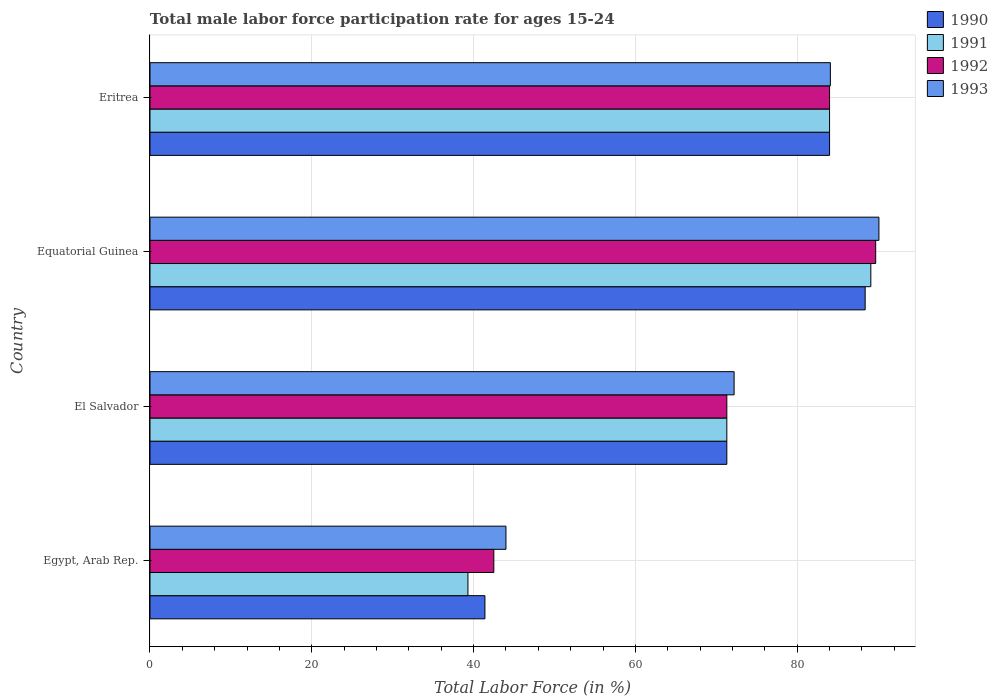How many different coloured bars are there?
Your response must be concise. 4. How many groups of bars are there?
Ensure brevity in your answer.  4. How many bars are there on the 2nd tick from the bottom?
Offer a very short reply. 4. What is the label of the 4th group of bars from the top?
Keep it short and to the point. Egypt, Arab Rep. What is the male labor force participation rate in 1990 in El Salvador?
Your response must be concise. 71.3. Across all countries, what is the maximum male labor force participation rate in 1990?
Your answer should be very brief. 88.4. In which country was the male labor force participation rate in 1991 maximum?
Offer a terse response. Equatorial Guinea. In which country was the male labor force participation rate in 1993 minimum?
Your answer should be compact. Egypt, Arab Rep. What is the total male labor force participation rate in 1991 in the graph?
Keep it short and to the point. 283.7. What is the difference between the male labor force participation rate in 1992 in Egypt, Arab Rep. and that in Equatorial Guinea?
Provide a succinct answer. -47.2. What is the difference between the male labor force participation rate in 1992 in Eritrea and the male labor force participation rate in 1990 in Equatorial Guinea?
Your response must be concise. -4.4. What is the average male labor force participation rate in 1993 per country?
Make the answer very short. 72.6. What is the difference between the male labor force participation rate in 1991 and male labor force participation rate in 1992 in Egypt, Arab Rep.?
Offer a terse response. -3.2. What is the ratio of the male labor force participation rate in 1993 in Egypt, Arab Rep. to that in Equatorial Guinea?
Your answer should be compact. 0.49. Is the male labor force participation rate in 1990 in Egypt, Arab Rep. less than that in Equatorial Guinea?
Offer a terse response. Yes. What is the difference between the highest and the second highest male labor force participation rate in 1992?
Make the answer very short. 5.7. What is the difference between the highest and the lowest male labor force participation rate in 1993?
Your answer should be very brief. 46.1. In how many countries, is the male labor force participation rate in 1992 greater than the average male labor force participation rate in 1992 taken over all countries?
Your answer should be compact. 2. Is it the case that in every country, the sum of the male labor force participation rate in 1993 and male labor force participation rate in 1990 is greater than the sum of male labor force participation rate in 1991 and male labor force participation rate in 1992?
Ensure brevity in your answer.  No. How many bars are there?
Make the answer very short. 16. Are all the bars in the graph horizontal?
Your answer should be very brief. Yes. What is the difference between two consecutive major ticks on the X-axis?
Provide a short and direct response. 20. Are the values on the major ticks of X-axis written in scientific E-notation?
Give a very brief answer. No. Does the graph contain grids?
Make the answer very short. Yes. How are the legend labels stacked?
Offer a very short reply. Vertical. What is the title of the graph?
Make the answer very short. Total male labor force participation rate for ages 15-24. Does "1975" appear as one of the legend labels in the graph?
Make the answer very short. No. What is the label or title of the X-axis?
Provide a short and direct response. Total Labor Force (in %). What is the label or title of the Y-axis?
Keep it short and to the point. Country. What is the Total Labor Force (in %) of 1990 in Egypt, Arab Rep.?
Make the answer very short. 41.4. What is the Total Labor Force (in %) in 1991 in Egypt, Arab Rep.?
Offer a very short reply. 39.3. What is the Total Labor Force (in %) in 1992 in Egypt, Arab Rep.?
Provide a succinct answer. 42.5. What is the Total Labor Force (in %) in 1993 in Egypt, Arab Rep.?
Your answer should be very brief. 44. What is the Total Labor Force (in %) in 1990 in El Salvador?
Keep it short and to the point. 71.3. What is the Total Labor Force (in %) in 1991 in El Salvador?
Offer a very short reply. 71.3. What is the Total Labor Force (in %) of 1992 in El Salvador?
Your response must be concise. 71.3. What is the Total Labor Force (in %) of 1993 in El Salvador?
Provide a succinct answer. 72.2. What is the Total Labor Force (in %) of 1990 in Equatorial Guinea?
Provide a short and direct response. 88.4. What is the Total Labor Force (in %) of 1991 in Equatorial Guinea?
Give a very brief answer. 89.1. What is the Total Labor Force (in %) of 1992 in Equatorial Guinea?
Ensure brevity in your answer.  89.7. What is the Total Labor Force (in %) in 1993 in Equatorial Guinea?
Your answer should be compact. 90.1. What is the Total Labor Force (in %) of 1990 in Eritrea?
Offer a terse response. 84. What is the Total Labor Force (in %) in 1991 in Eritrea?
Your answer should be compact. 84. What is the Total Labor Force (in %) in 1992 in Eritrea?
Provide a succinct answer. 84. What is the Total Labor Force (in %) in 1993 in Eritrea?
Make the answer very short. 84.1. Across all countries, what is the maximum Total Labor Force (in %) of 1990?
Keep it short and to the point. 88.4. Across all countries, what is the maximum Total Labor Force (in %) of 1991?
Your answer should be very brief. 89.1. Across all countries, what is the maximum Total Labor Force (in %) in 1992?
Ensure brevity in your answer.  89.7. Across all countries, what is the maximum Total Labor Force (in %) of 1993?
Provide a succinct answer. 90.1. Across all countries, what is the minimum Total Labor Force (in %) in 1990?
Ensure brevity in your answer.  41.4. Across all countries, what is the minimum Total Labor Force (in %) of 1991?
Your answer should be compact. 39.3. Across all countries, what is the minimum Total Labor Force (in %) of 1992?
Make the answer very short. 42.5. What is the total Total Labor Force (in %) in 1990 in the graph?
Keep it short and to the point. 285.1. What is the total Total Labor Force (in %) of 1991 in the graph?
Provide a short and direct response. 283.7. What is the total Total Labor Force (in %) of 1992 in the graph?
Your answer should be very brief. 287.5. What is the total Total Labor Force (in %) in 1993 in the graph?
Keep it short and to the point. 290.4. What is the difference between the Total Labor Force (in %) in 1990 in Egypt, Arab Rep. and that in El Salvador?
Provide a short and direct response. -29.9. What is the difference between the Total Labor Force (in %) in 1991 in Egypt, Arab Rep. and that in El Salvador?
Offer a very short reply. -32. What is the difference between the Total Labor Force (in %) of 1992 in Egypt, Arab Rep. and that in El Salvador?
Your answer should be compact. -28.8. What is the difference between the Total Labor Force (in %) in 1993 in Egypt, Arab Rep. and that in El Salvador?
Make the answer very short. -28.2. What is the difference between the Total Labor Force (in %) in 1990 in Egypt, Arab Rep. and that in Equatorial Guinea?
Keep it short and to the point. -47. What is the difference between the Total Labor Force (in %) in 1991 in Egypt, Arab Rep. and that in Equatorial Guinea?
Provide a succinct answer. -49.8. What is the difference between the Total Labor Force (in %) of 1992 in Egypt, Arab Rep. and that in Equatorial Guinea?
Your response must be concise. -47.2. What is the difference between the Total Labor Force (in %) in 1993 in Egypt, Arab Rep. and that in Equatorial Guinea?
Your answer should be very brief. -46.1. What is the difference between the Total Labor Force (in %) in 1990 in Egypt, Arab Rep. and that in Eritrea?
Your answer should be very brief. -42.6. What is the difference between the Total Labor Force (in %) in 1991 in Egypt, Arab Rep. and that in Eritrea?
Keep it short and to the point. -44.7. What is the difference between the Total Labor Force (in %) in 1992 in Egypt, Arab Rep. and that in Eritrea?
Give a very brief answer. -41.5. What is the difference between the Total Labor Force (in %) of 1993 in Egypt, Arab Rep. and that in Eritrea?
Offer a very short reply. -40.1. What is the difference between the Total Labor Force (in %) of 1990 in El Salvador and that in Equatorial Guinea?
Offer a terse response. -17.1. What is the difference between the Total Labor Force (in %) of 1991 in El Salvador and that in Equatorial Guinea?
Your answer should be very brief. -17.8. What is the difference between the Total Labor Force (in %) in 1992 in El Salvador and that in Equatorial Guinea?
Ensure brevity in your answer.  -18.4. What is the difference between the Total Labor Force (in %) of 1993 in El Salvador and that in Equatorial Guinea?
Your answer should be compact. -17.9. What is the difference between the Total Labor Force (in %) in 1991 in El Salvador and that in Eritrea?
Make the answer very short. -12.7. What is the difference between the Total Labor Force (in %) in 1993 in El Salvador and that in Eritrea?
Keep it short and to the point. -11.9. What is the difference between the Total Labor Force (in %) of 1990 in Equatorial Guinea and that in Eritrea?
Your answer should be very brief. 4.4. What is the difference between the Total Labor Force (in %) of 1991 in Equatorial Guinea and that in Eritrea?
Offer a terse response. 5.1. What is the difference between the Total Labor Force (in %) of 1992 in Equatorial Guinea and that in Eritrea?
Ensure brevity in your answer.  5.7. What is the difference between the Total Labor Force (in %) of 1990 in Egypt, Arab Rep. and the Total Labor Force (in %) of 1991 in El Salvador?
Offer a very short reply. -29.9. What is the difference between the Total Labor Force (in %) of 1990 in Egypt, Arab Rep. and the Total Labor Force (in %) of 1992 in El Salvador?
Your response must be concise. -29.9. What is the difference between the Total Labor Force (in %) in 1990 in Egypt, Arab Rep. and the Total Labor Force (in %) in 1993 in El Salvador?
Your answer should be compact. -30.8. What is the difference between the Total Labor Force (in %) of 1991 in Egypt, Arab Rep. and the Total Labor Force (in %) of 1992 in El Salvador?
Make the answer very short. -32. What is the difference between the Total Labor Force (in %) of 1991 in Egypt, Arab Rep. and the Total Labor Force (in %) of 1993 in El Salvador?
Offer a terse response. -32.9. What is the difference between the Total Labor Force (in %) of 1992 in Egypt, Arab Rep. and the Total Labor Force (in %) of 1993 in El Salvador?
Your answer should be compact. -29.7. What is the difference between the Total Labor Force (in %) in 1990 in Egypt, Arab Rep. and the Total Labor Force (in %) in 1991 in Equatorial Guinea?
Offer a terse response. -47.7. What is the difference between the Total Labor Force (in %) of 1990 in Egypt, Arab Rep. and the Total Labor Force (in %) of 1992 in Equatorial Guinea?
Your answer should be very brief. -48.3. What is the difference between the Total Labor Force (in %) of 1990 in Egypt, Arab Rep. and the Total Labor Force (in %) of 1993 in Equatorial Guinea?
Provide a short and direct response. -48.7. What is the difference between the Total Labor Force (in %) in 1991 in Egypt, Arab Rep. and the Total Labor Force (in %) in 1992 in Equatorial Guinea?
Your response must be concise. -50.4. What is the difference between the Total Labor Force (in %) of 1991 in Egypt, Arab Rep. and the Total Labor Force (in %) of 1993 in Equatorial Guinea?
Offer a very short reply. -50.8. What is the difference between the Total Labor Force (in %) of 1992 in Egypt, Arab Rep. and the Total Labor Force (in %) of 1993 in Equatorial Guinea?
Make the answer very short. -47.6. What is the difference between the Total Labor Force (in %) of 1990 in Egypt, Arab Rep. and the Total Labor Force (in %) of 1991 in Eritrea?
Offer a very short reply. -42.6. What is the difference between the Total Labor Force (in %) of 1990 in Egypt, Arab Rep. and the Total Labor Force (in %) of 1992 in Eritrea?
Give a very brief answer. -42.6. What is the difference between the Total Labor Force (in %) in 1990 in Egypt, Arab Rep. and the Total Labor Force (in %) in 1993 in Eritrea?
Offer a very short reply. -42.7. What is the difference between the Total Labor Force (in %) in 1991 in Egypt, Arab Rep. and the Total Labor Force (in %) in 1992 in Eritrea?
Keep it short and to the point. -44.7. What is the difference between the Total Labor Force (in %) in 1991 in Egypt, Arab Rep. and the Total Labor Force (in %) in 1993 in Eritrea?
Your response must be concise. -44.8. What is the difference between the Total Labor Force (in %) in 1992 in Egypt, Arab Rep. and the Total Labor Force (in %) in 1993 in Eritrea?
Offer a very short reply. -41.6. What is the difference between the Total Labor Force (in %) of 1990 in El Salvador and the Total Labor Force (in %) of 1991 in Equatorial Guinea?
Your answer should be very brief. -17.8. What is the difference between the Total Labor Force (in %) in 1990 in El Salvador and the Total Labor Force (in %) in 1992 in Equatorial Guinea?
Your answer should be compact. -18.4. What is the difference between the Total Labor Force (in %) in 1990 in El Salvador and the Total Labor Force (in %) in 1993 in Equatorial Guinea?
Give a very brief answer. -18.8. What is the difference between the Total Labor Force (in %) in 1991 in El Salvador and the Total Labor Force (in %) in 1992 in Equatorial Guinea?
Offer a very short reply. -18.4. What is the difference between the Total Labor Force (in %) of 1991 in El Salvador and the Total Labor Force (in %) of 1993 in Equatorial Guinea?
Ensure brevity in your answer.  -18.8. What is the difference between the Total Labor Force (in %) in 1992 in El Salvador and the Total Labor Force (in %) in 1993 in Equatorial Guinea?
Keep it short and to the point. -18.8. What is the difference between the Total Labor Force (in %) in 1990 in El Salvador and the Total Labor Force (in %) in 1992 in Eritrea?
Your answer should be compact. -12.7. What is the difference between the Total Labor Force (in %) in 1990 in El Salvador and the Total Labor Force (in %) in 1993 in Eritrea?
Your answer should be very brief. -12.8. What is the difference between the Total Labor Force (in %) in 1991 in El Salvador and the Total Labor Force (in %) in 1992 in Eritrea?
Your answer should be very brief. -12.7. What is the difference between the Total Labor Force (in %) in 1991 in El Salvador and the Total Labor Force (in %) in 1993 in Eritrea?
Your answer should be very brief. -12.8. What is the difference between the Total Labor Force (in %) in 1992 in El Salvador and the Total Labor Force (in %) in 1993 in Eritrea?
Provide a succinct answer. -12.8. What is the difference between the Total Labor Force (in %) of 1990 in Equatorial Guinea and the Total Labor Force (in %) of 1991 in Eritrea?
Give a very brief answer. 4.4. What is the difference between the Total Labor Force (in %) in 1991 in Equatorial Guinea and the Total Labor Force (in %) in 1992 in Eritrea?
Make the answer very short. 5.1. What is the difference between the Total Labor Force (in %) in 1991 in Equatorial Guinea and the Total Labor Force (in %) in 1993 in Eritrea?
Make the answer very short. 5. What is the difference between the Total Labor Force (in %) of 1992 in Equatorial Guinea and the Total Labor Force (in %) of 1993 in Eritrea?
Your answer should be compact. 5.6. What is the average Total Labor Force (in %) in 1990 per country?
Offer a terse response. 71.28. What is the average Total Labor Force (in %) of 1991 per country?
Provide a short and direct response. 70.92. What is the average Total Labor Force (in %) of 1992 per country?
Give a very brief answer. 71.88. What is the average Total Labor Force (in %) of 1993 per country?
Give a very brief answer. 72.6. What is the difference between the Total Labor Force (in %) in 1990 and Total Labor Force (in %) in 1991 in Egypt, Arab Rep.?
Your answer should be compact. 2.1. What is the difference between the Total Labor Force (in %) of 1990 and Total Labor Force (in %) of 1993 in Egypt, Arab Rep.?
Provide a short and direct response. -2.6. What is the difference between the Total Labor Force (in %) of 1991 and Total Labor Force (in %) of 1992 in Egypt, Arab Rep.?
Your answer should be very brief. -3.2. What is the difference between the Total Labor Force (in %) in 1990 and Total Labor Force (in %) in 1991 in El Salvador?
Provide a short and direct response. 0. What is the difference between the Total Labor Force (in %) in 1990 and Total Labor Force (in %) in 1991 in Equatorial Guinea?
Offer a very short reply. -0.7. What is the difference between the Total Labor Force (in %) in 1990 and Total Labor Force (in %) in 1993 in Equatorial Guinea?
Make the answer very short. -1.7. What is the difference between the Total Labor Force (in %) in 1991 and Total Labor Force (in %) in 1992 in Equatorial Guinea?
Offer a terse response. -0.6. What is the difference between the Total Labor Force (in %) in 1992 and Total Labor Force (in %) in 1993 in Equatorial Guinea?
Provide a succinct answer. -0.4. What is the difference between the Total Labor Force (in %) of 1990 and Total Labor Force (in %) of 1992 in Eritrea?
Offer a terse response. 0. What is the difference between the Total Labor Force (in %) in 1991 and Total Labor Force (in %) in 1992 in Eritrea?
Your response must be concise. 0. What is the ratio of the Total Labor Force (in %) in 1990 in Egypt, Arab Rep. to that in El Salvador?
Keep it short and to the point. 0.58. What is the ratio of the Total Labor Force (in %) of 1991 in Egypt, Arab Rep. to that in El Salvador?
Keep it short and to the point. 0.55. What is the ratio of the Total Labor Force (in %) in 1992 in Egypt, Arab Rep. to that in El Salvador?
Your answer should be very brief. 0.6. What is the ratio of the Total Labor Force (in %) in 1993 in Egypt, Arab Rep. to that in El Salvador?
Give a very brief answer. 0.61. What is the ratio of the Total Labor Force (in %) of 1990 in Egypt, Arab Rep. to that in Equatorial Guinea?
Ensure brevity in your answer.  0.47. What is the ratio of the Total Labor Force (in %) in 1991 in Egypt, Arab Rep. to that in Equatorial Guinea?
Offer a terse response. 0.44. What is the ratio of the Total Labor Force (in %) of 1992 in Egypt, Arab Rep. to that in Equatorial Guinea?
Your response must be concise. 0.47. What is the ratio of the Total Labor Force (in %) in 1993 in Egypt, Arab Rep. to that in Equatorial Guinea?
Keep it short and to the point. 0.49. What is the ratio of the Total Labor Force (in %) of 1990 in Egypt, Arab Rep. to that in Eritrea?
Provide a short and direct response. 0.49. What is the ratio of the Total Labor Force (in %) of 1991 in Egypt, Arab Rep. to that in Eritrea?
Offer a terse response. 0.47. What is the ratio of the Total Labor Force (in %) of 1992 in Egypt, Arab Rep. to that in Eritrea?
Your answer should be very brief. 0.51. What is the ratio of the Total Labor Force (in %) in 1993 in Egypt, Arab Rep. to that in Eritrea?
Your answer should be very brief. 0.52. What is the ratio of the Total Labor Force (in %) of 1990 in El Salvador to that in Equatorial Guinea?
Offer a very short reply. 0.81. What is the ratio of the Total Labor Force (in %) of 1991 in El Salvador to that in Equatorial Guinea?
Offer a terse response. 0.8. What is the ratio of the Total Labor Force (in %) in 1992 in El Salvador to that in Equatorial Guinea?
Your answer should be compact. 0.79. What is the ratio of the Total Labor Force (in %) in 1993 in El Salvador to that in Equatorial Guinea?
Your answer should be compact. 0.8. What is the ratio of the Total Labor Force (in %) of 1990 in El Salvador to that in Eritrea?
Offer a very short reply. 0.85. What is the ratio of the Total Labor Force (in %) of 1991 in El Salvador to that in Eritrea?
Your answer should be very brief. 0.85. What is the ratio of the Total Labor Force (in %) in 1992 in El Salvador to that in Eritrea?
Make the answer very short. 0.85. What is the ratio of the Total Labor Force (in %) in 1993 in El Salvador to that in Eritrea?
Ensure brevity in your answer.  0.86. What is the ratio of the Total Labor Force (in %) of 1990 in Equatorial Guinea to that in Eritrea?
Keep it short and to the point. 1.05. What is the ratio of the Total Labor Force (in %) in 1991 in Equatorial Guinea to that in Eritrea?
Your answer should be very brief. 1.06. What is the ratio of the Total Labor Force (in %) in 1992 in Equatorial Guinea to that in Eritrea?
Ensure brevity in your answer.  1.07. What is the ratio of the Total Labor Force (in %) of 1993 in Equatorial Guinea to that in Eritrea?
Your answer should be very brief. 1.07. What is the difference between the highest and the second highest Total Labor Force (in %) in 1990?
Provide a succinct answer. 4.4. What is the difference between the highest and the lowest Total Labor Force (in %) of 1991?
Your answer should be compact. 49.8. What is the difference between the highest and the lowest Total Labor Force (in %) in 1992?
Provide a short and direct response. 47.2. What is the difference between the highest and the lowest Total Labor Force (in %) in 1993?
Offer a terse response. 46.1. 